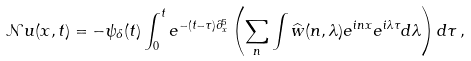Convert formula to latex. <formula><loc_0><loc_0><loc_500><loc_500>\mathcal { N } u ( x , t ) = - \psi _ { \delta } ( t ) \int _ { 0 } ^ { t } e ^ { - ( t - \tau ) \partial _ { x } ^ { 5 } } \left ( \sum _ { n } \int \widehat { w } ( n , \lambda ) e ^ { i n x } e ^ { i \lambda \tau } d \lambda \right ) d \tau \, ,</formula> 